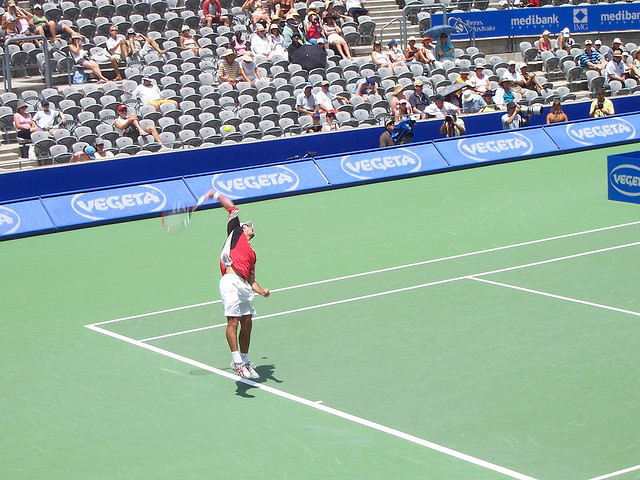Identify and read out the text in this image. VEGETA VEGETA VEGETA VEGETA VEGETA medibank medibank 